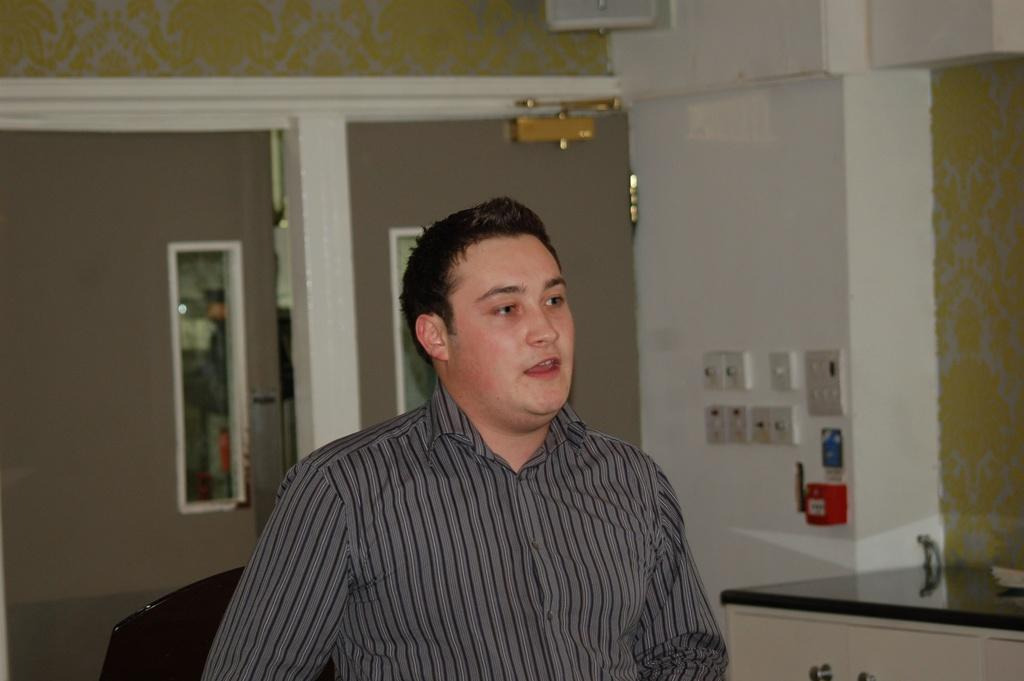Who or what is present in the image? There is a person in the image. What piece of furniture can be seen in the image? There is a table in the image. What other type of furniture is visible in the image? There is a cupboard in the image. What can be used for reflecting light or images in the image? There are mirrors in the image. What is used for controlling electrical devices in the image? There are switch boards on a wall in the image. What type of pain is the person experiencing in the image? There is no indication of pain or discomfort in the image; the person appears to be standing or sitting. What causes friction between the person and the table in the image? There is no friction between the person and the table in the image; they are simply present in the same space. 